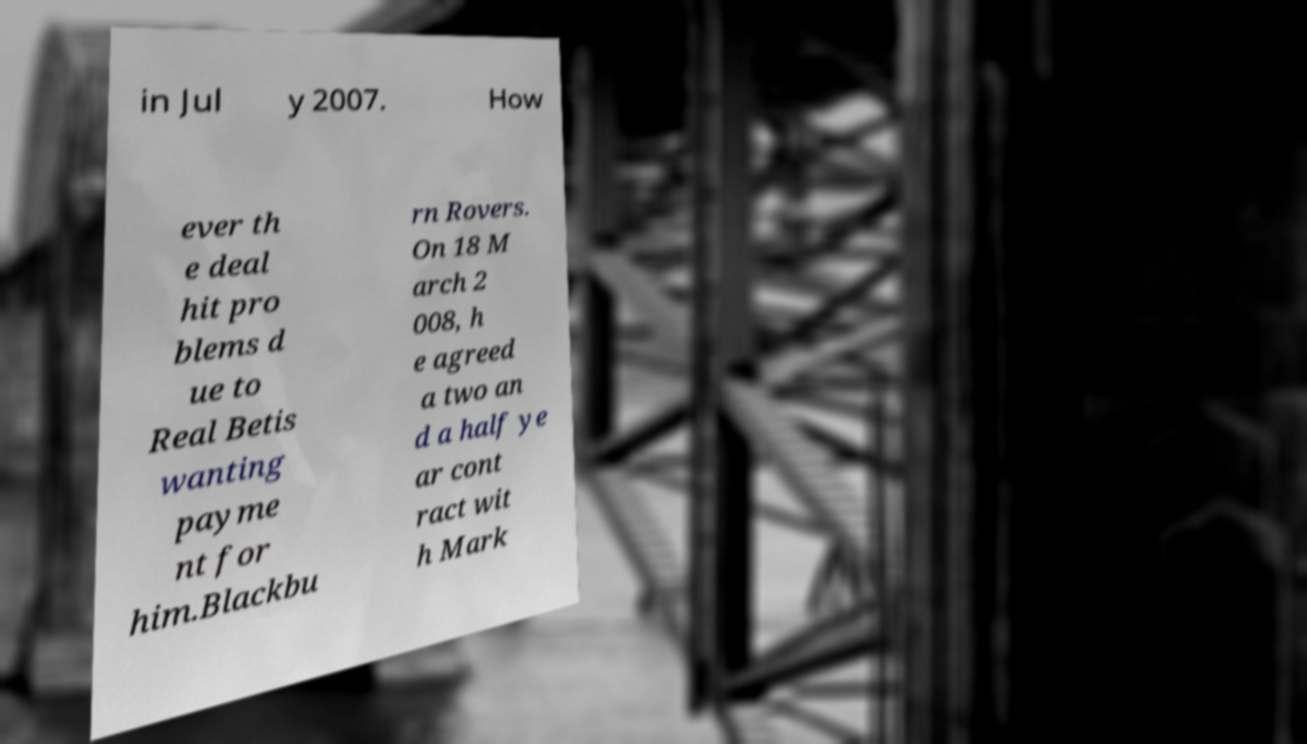Please identify and transcribe the text found in this image. in Jul y 2007. How ever th e deal hit pro blems d ue to Real Betis wanting payme nt for him.Blackbu rn Rovers. On 18 M arch 2 008, h e agreed a two an d a half ye ar cont ract wit h Mark 